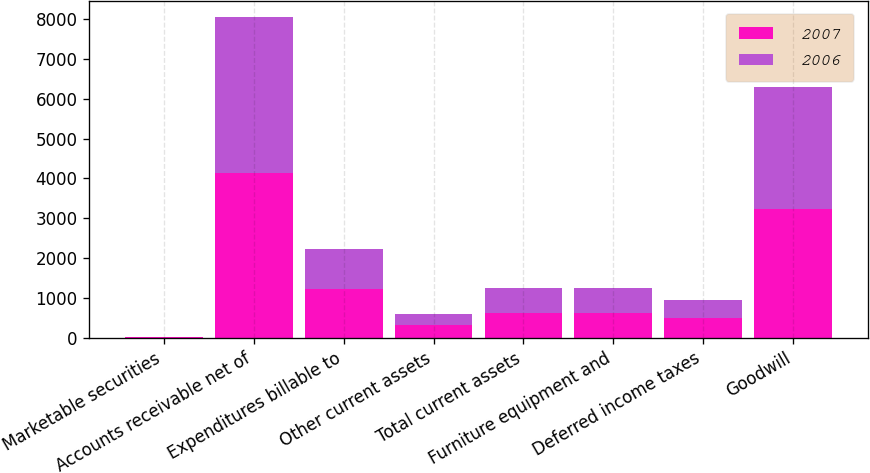Convert chart. <chart><loc_0><loc_0><loc_500><loc_500><stacked_bar_chart><ecel><fcel>Marketable securities<fcel>Accounts receivable net of<fcel>Expenditures billable to<fcel>Other current assets<fcel>Total current assets<fcel>Furniture equipment and<fcel>Deferred income taxes<fcel>Goodwill<nl><fcel>2007<fcel>22.5<fcel>4132.7<fcel>1210.6<fcel>305.1<fcel>622<fcel>620<fcel>479.9<fcel>3231.6<nl><fcel>2006<fcel>1.4<fcel>3934.9<fcel>1021.4<fcel>295.4<fcel>622<fcel>624<fcel>476.5<fcel>3067.8<nl></chart> 